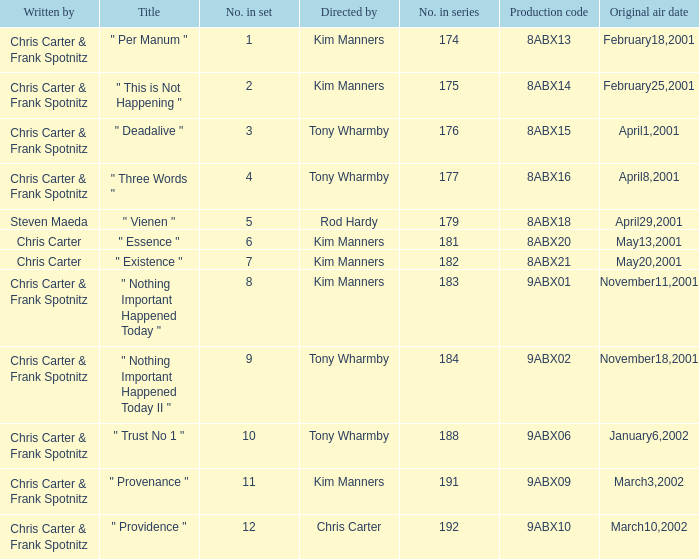What is the episode number that has production code 8abx15? 176.0. Can you give me this table as a dict? {'header': ['Written by', 'Title', 'No. in set', 'Directed by', 'No. in series', 'Production code', 'Original air date'], 'rows': [['Chris Carter & Frank Spotnitz', '" Per Manum "', '1', 'Kim Manners', '174', '8ABX13', 'February18,2001'], ['Chris Carter & Frank Spotnitz', '" This is Not Happening "', '2', 'Kim Manners', '175', '8ABX14', 'February25,2001'], ['Chris Carter & Frank Spotnitz', '" Deadalive "', '3', 'Tony Wharmby', '176', '8ABX15', 'April1,2001'], ['Chris Carter & Frank Spotnitz', '" Three Words "', '4', 'Tony Wharmby', '177', '8ABX16', 'April8,2001'], ['Steven Maeda', '" Vienen "', '5', 'Rod Hardy', '179', '8ABX18', 'April29,2001'], ['Chris Carter', '" Essence "', '6', 'Kim Manners', '181', '8ABX20', 'May13,2001'], ['Chris Carter', '" Existence "', '7', 'Kim Manners', '182', '8ABX21', 'May20,2001'], ['Chris Carter & Frank Spotnitz', '" Nothing Important Happened Today "', '8', 'Kim Manners', '183', '9ABX01', 'November11,2001'], ['Chris Carter & Frank Spotnitz', '" Nothing Important Happened Today II "', '9', 'Tony Wharmby', '184', '9ABX02', 'November18,2001'], ['Chris Carter & Frank Spotnitz', '" Trust No 1 "', '10', 'Tony Wharmby', '188', '9ABX06', 'January6,2002'], ['Chris Carter & Frank Spotnitz', '" Provenance "', '11', 'Kim Manners', '191', '9ABX09', 'March3,2002'], ['Chris Carter & Frank Spotnitz', '" Providence "', '12', 'Chris Carter', '192', '9ABX10', 'March10,2002']]} 